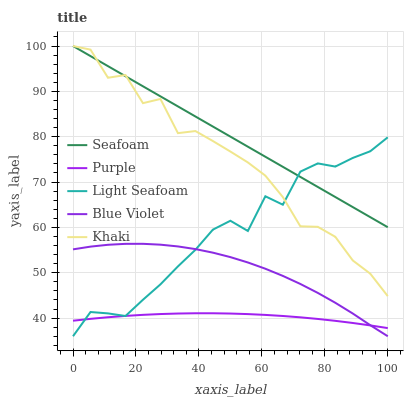Does Light Seafoam have the minimum area under the curve?
Answer yes or no. No. Does Light Seafoam have the maximum area under the curve?
Answer yes or no. No. Is Light Seafoam the smoothest?
Answer yes or no. No. Is Light Seafoam the roughest?
Answer yes or no. No. Does Khaki have the lowest value?
Answer yes or no. No. Does Light Seafoam have the highest value?
Answer yes or no. No. Is Blue Violet less than Khaki?
Answer yes or no. Yes. Is Khaki greater than Blue Violet?
Answer yes or no. Yes. Does Blue Violet intersect Khaki?
Answer yes or no. No. 